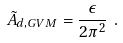<formula> <loc_0><loc_0><loc_500><loc_500>\tilde { A } _ { d , { G V M } } = \frac { \epsilon } { 2 \pi ^ { 2 } } \ .</formula> 